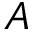Convert formula to latex. <formula><loc_0><loc_0><loc_500><loc_500>A</formula> 